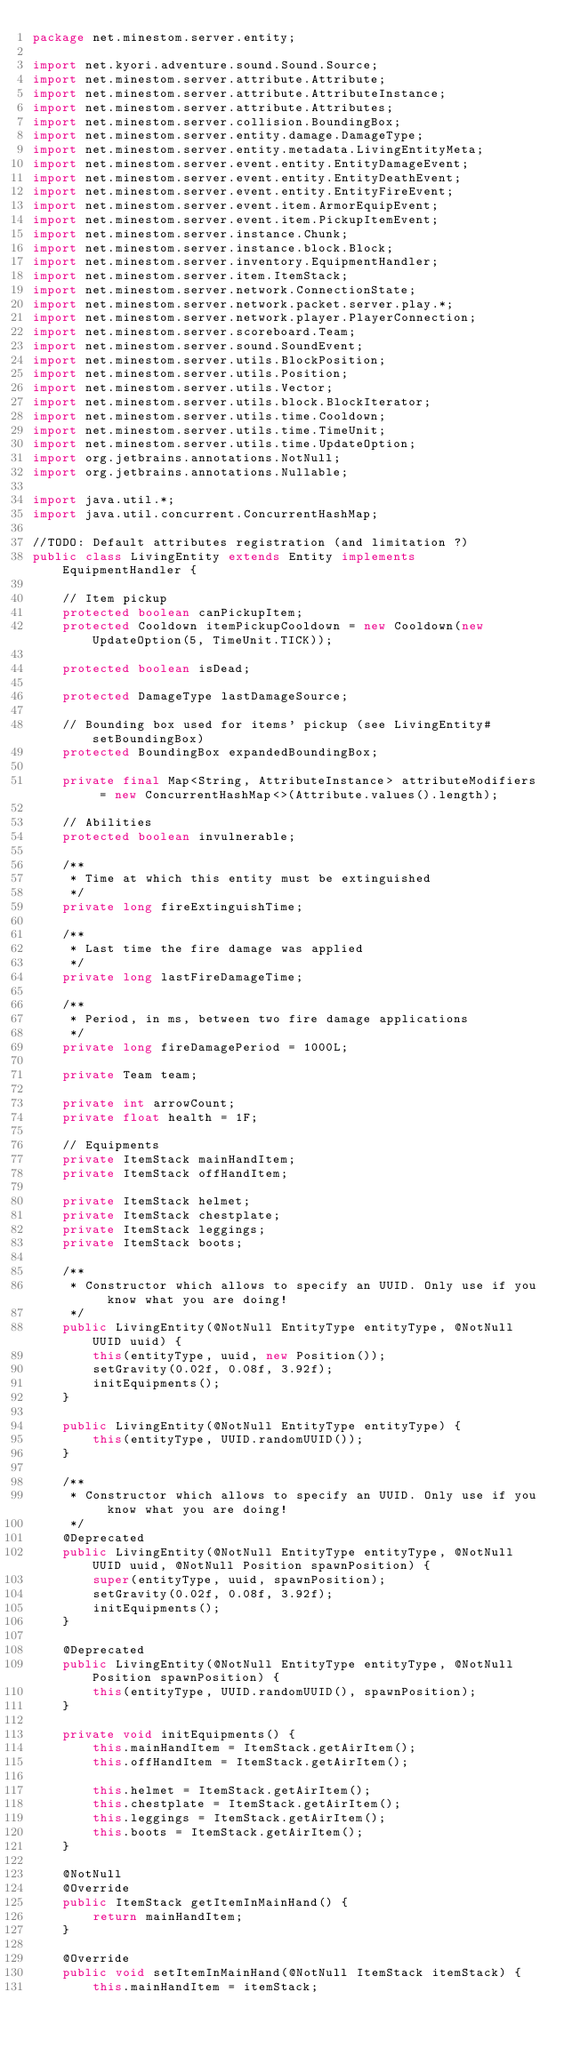Convert code to text. <code><loc_0><loc_0><loc_500><loc_500><_Java_>package net.minestom.server.entity;

import net.kyori.adventure.sound.Sound.Source;
import net.minestom.server.attribute.Attribute;
import net.minestom.server.attribute.AttributeInstance;
import net.minestom.server.attribute.Attributes;
import net.minestom.server.collision.BoundingBox;
import net.minestom.server.entity.damage.DamageType;
import net.minestom.server.entity.metadata.LivingEntityMeta;
import net.minestom.server.event.entity.EntityDamageEvent;
import net.minestom.server.event.entity.EntityDeathEvent;
import net.minestom.server.event.entity.EntityFireEvent;
import net.minestom.server.event.item.ArmorEquipEvent;
import net.minestom.server.event.item.PickupItemEvent;
import net.minestom.server.instance.Chunk;
import net.minestom.server.instance.block.Block;
import net.minestom.server.inventory.EquipmentHandler;
import net.minestom.server.item.ItemStack;
import net.minestom.server.network.ConnectionState;
import net.minestom.server.network.packet.server.play.*;
import net.minestom.server.network.player.PlayerConnection;
import net.minestom.server.scoreboard.Team;
import net.minestom.server.sound.SoundEvent;
import net.minestom.server.utils.BlockPosition;
import net.minestom.server.utils.Position;
import net.minestom.server.utils.Vector;
import net.minestom.server.utils.block.BlockIterator;
import net.minestom.server.utils.time.Cooldown;
import net.minestom.server.utils.time.TimeUnit;
import net.minestom.server.utils.time.UpdateOption;
import org.jetbrains.annotations.NotNull;
import org.jetbrains.annotations.Nullable;

import java.util.*;
import java.util.concurrent.ConcurrentHashMap;

//TODO: Default attributes registration (and limitation ?)
public class LivingEntity extends Entity implements EquipmentHandler {

    // Item pickup
    protected boolean canPickupItem;
    protected Cooldown itemPickupCooldown = new Cooldown(new UpdateOption(5, TimeUnit.TICK));

    protected boolean isDead;

    protected DamageType lastDamageSource;

    // Bounding box used for items' pickup (see LivingEntity#setBoundingBox)
    protected BoundingBox expandedBoundingBox;

    private final Map<String, AttributeInstance> attributeModifiers = new ConcurrentHashMap<>(Attribute.values().length);

    // Abilities
    protected boolean invulnerable;

    /**
     * Time at which this entity must be extinguished
     */
    private long fireExtinguishTime;

    /**
     * Last time the fire damage was applied
     */
    private long lastFireDamageTime;

    /**
     * Period, in ms, between two fire damage applications
     */
    private long fireDamagePeriod = 1000L;

    private Team team;

    private int arrowCount;
    private float health = 1F;

    // Equipments
    private ItemStack mainHandItem;
    private ItemStack offHandItem;

    private ItemStack helmet;
    private ItemStack chestplate;
    private ItemStack leggings;
    private ItemStack boots;

    /**
     * Constructor which allows to specify an UUID. Only use if you know what you are doing!
     */
    public LivingEntity(@NotNull EntityType entityType, @NotNull UUID uuid) {
        this(entityType, uuid, new Position());
        setGravity(0.02f, 0.08f, 3.92f);
        initEquipments();
    }

    public LivingEntity(@NotNull EntityType entityType) {
        this(entityType, UUID.randomUUID());
    }

    /**
     * Constructor which allows to specify an UUID. Only use if you know what you are doing!
     */
    @Deprecated
    public LivingEntity(@NotNull EntityType entityType, @NotNull UUID uuid, @NotNull Position spawnPosition) {
        super(entityType, uuid, spawnPosition);
        setGravity(0.02f, 0.08f, 3.92f);
        initEquipments();
    }

    @Deprecated
    public LivingEntity(@NotNull EntityType entityType, @NotNull Position spawnPosition) {
        this(entityType, UUID.randomUUID(), spawnPosition);
    }

    private void initEquipments() {
        this.mainHandItem = ItemStack.getAirItem();
        this.offHandItem = ItemStack.getAirItem();

        this.helmet = ItemStack.getAirItem();
        this.chestplate = ItemStack.getAirItem();
        this.leggings = ItemStack.getAirItem();
        this.boots = ItemStack.getAirItem();
    }

    @NotNull
    @Override
    public ItemStack getItemInMainHand() {
        return mainHandItem;
    }

    @Override
    public void setItemInMainHand(@NotNull ItemStack itemStack) {
        this.mainHandItem = itemStack;</code> 